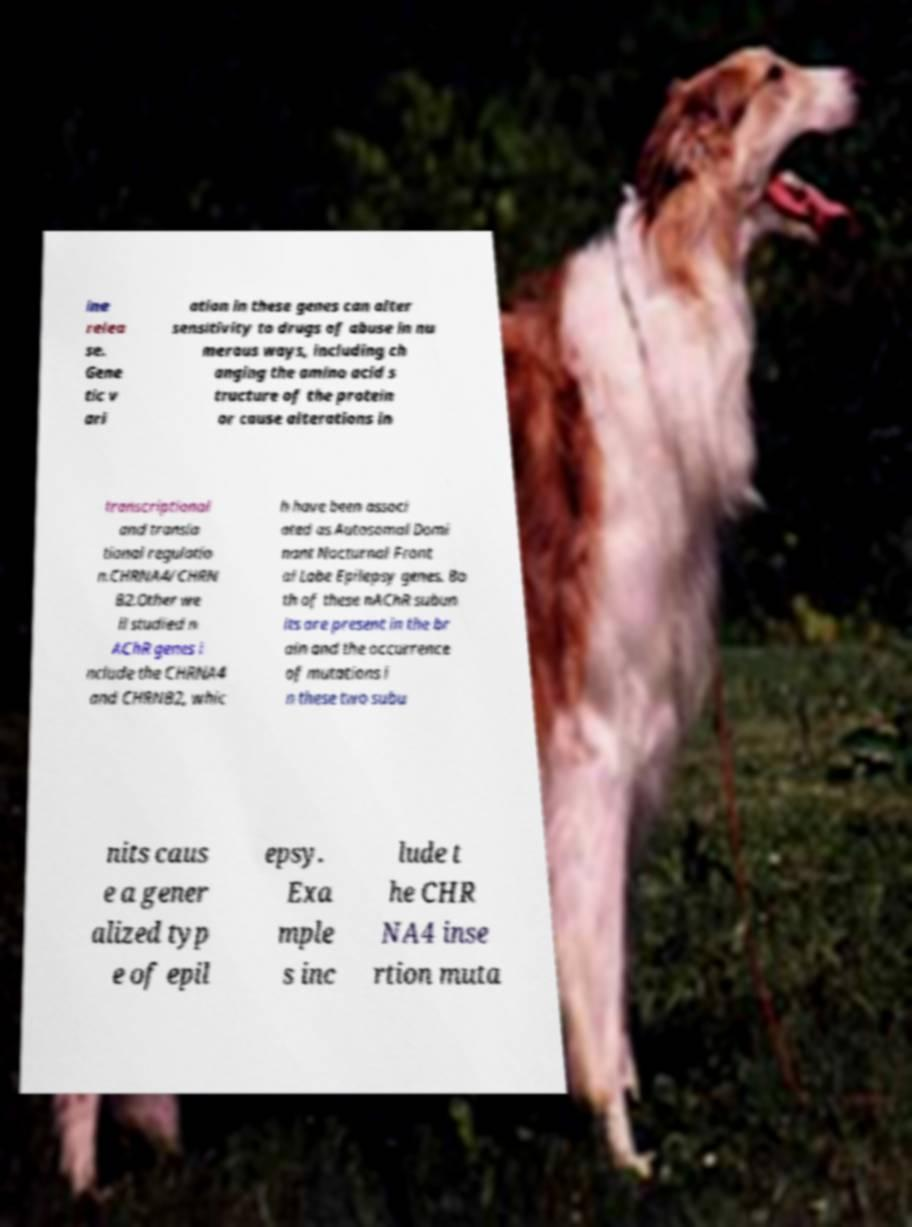Please read and relay the text visible in this image. What does it say? ine relea se. Gene tic v ari ation in these genes can alter sensitivity to drugs of abuse in nu merous ways, including ch anging the amino acid s tructure of the protein or cause alterations in transcriptional and transla tional regulatio n.CHRNA4/CHRN B2.Other we ll studied n AChR genes i nclude the CHRNA4 and CHRNB2, whic h have been associ ated as Autosomal Domi nant Nocturnal Front al Lobe Epilepsy genes. Bo th of these nAChR subun its are present in the br ain and the occurrence of mutations i n these two subu nits caus e a gener alized typ e of epil epsy. Exa mple s inc lude t he CHR NA4 inse rtion muta 